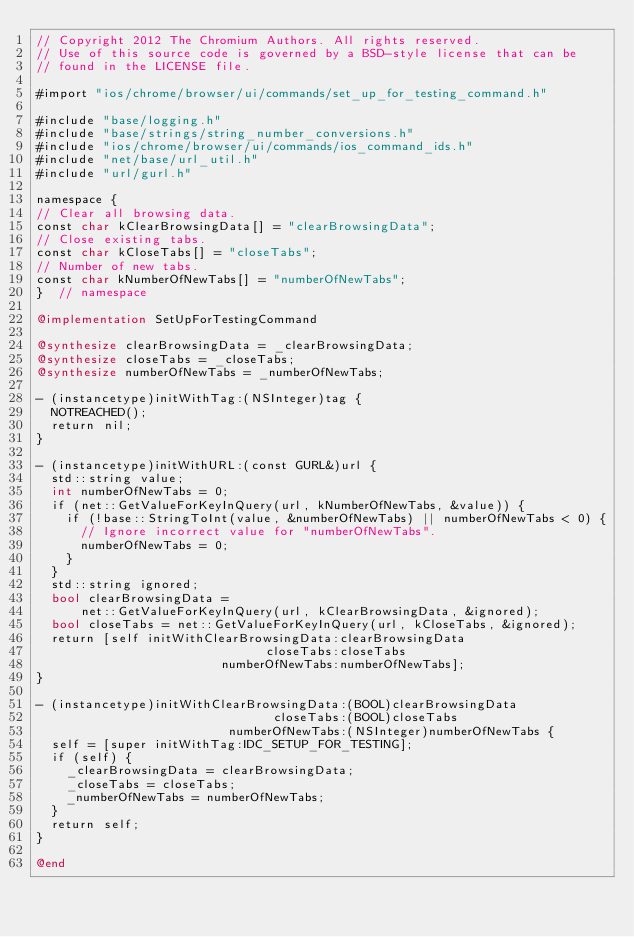<code> <loc_0><loc_0><loc_500><loc_500><_ObjectiveC_>// Copyright 2012 The Chromium Authors. All rights reserved.
// Use of this source code is governed by a BSD-style license that can be
// found in the LICENSE file.

#import "ios/chrome/browser/ui/commands/set_up_for_testing_command.h"

#include "base/logging.h"
#include "base/strings/string_number_conversions.h"
#include "ios/chrome/browser/ui/commands/ios_command_ids.h"
#include "net/base/url_util.h"
#include "url/gurl.h"

namespace {
// Clear all browsing data.
const char kClearBrowsingData[] = "clearBrowsingData";
// Close existing tabs.
const char kCloseTabs[] = "closeTabs";
// Number of new tabs.
const char kNumberOfNewTabs[] = "numberOfNewTabs";
}  // namespace

@implementation SetUpForTestingCommand

@synthesize clearBrowsingData = _clearBrowsingData;
@synthesize closeTabs = _closeTabs;
@synthesize numberOfNewTabs = _numberOfNewTabs;

- (instancetype)initWithTag:(NSInteger)tag {
  NOTREACHED();
  return nil;
}

- (instancetype)initWithURL:(const GURL&)url {
  std::string value;
  int numberOfNewTabs = 0;
  if (net::GetValueForKeyInQuery(url, kNumberOfNewTabs, &value)) {
    if (!base::StringToInt(value, &numberOfNewTabs) || numberOfNewTabs < 0) {
      // Ignore incorrect value for "numberOfNewTabs".
      numberOfNewTabs = 0;
    }
  }
  std::string ignored;
  bool clearBrowsingData =
      net::GetValueForKeyInQuery(url, kClearBrowsingData, &ignored);
  bool closeTabs = net::GetValueForKeyInQuery(url, kCloseTabs, &ignored);
  return [self initWithClearBrowsingData:clearBrowsingData
                               closeTabs:closeTabs
                         numberOfNewTabs:numberOfNewTabs];
}

- (instancetype)initWithClearBrowsingData:(BOOL)clearBrowsingData
                                closeTabs:(BOOL)closeTabs
                          numberOfNewTabs:(NSInteger)numberOfNewTabs {
  self = [super initWithTag:IDC_SETUP_FOR_TESTING];
  if (self) {
    _clearBrowsingData = clearBrowsingData;
    _closeTabs = closeTabs;
    _numberOfNewTabs = numberOfNewTabs;
  }
  return self;
}

@end
</code> 